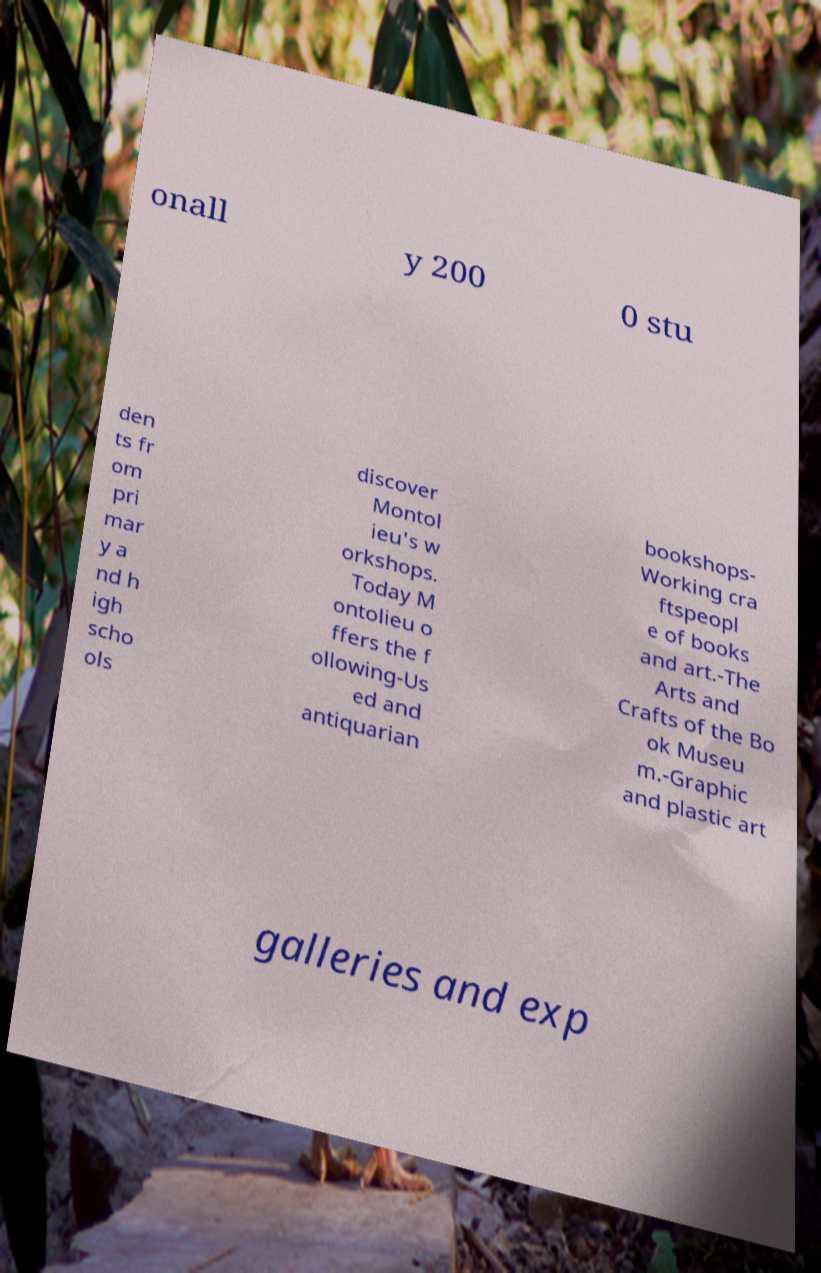Please identify and transcribe the text found in this image. onall y 200 0 stu den ts fr om pri mar y a nd h igh scho ols discover Montol ieu's w orkshops. Today M ontolieu o ffers the f ollowing-Us ed and antiquarian bookshops- Working cra ftspeopl e of books and art.-The Arts and Crafts of the Bo ok Museu m.-Graphic and plastic art galleries and exp 